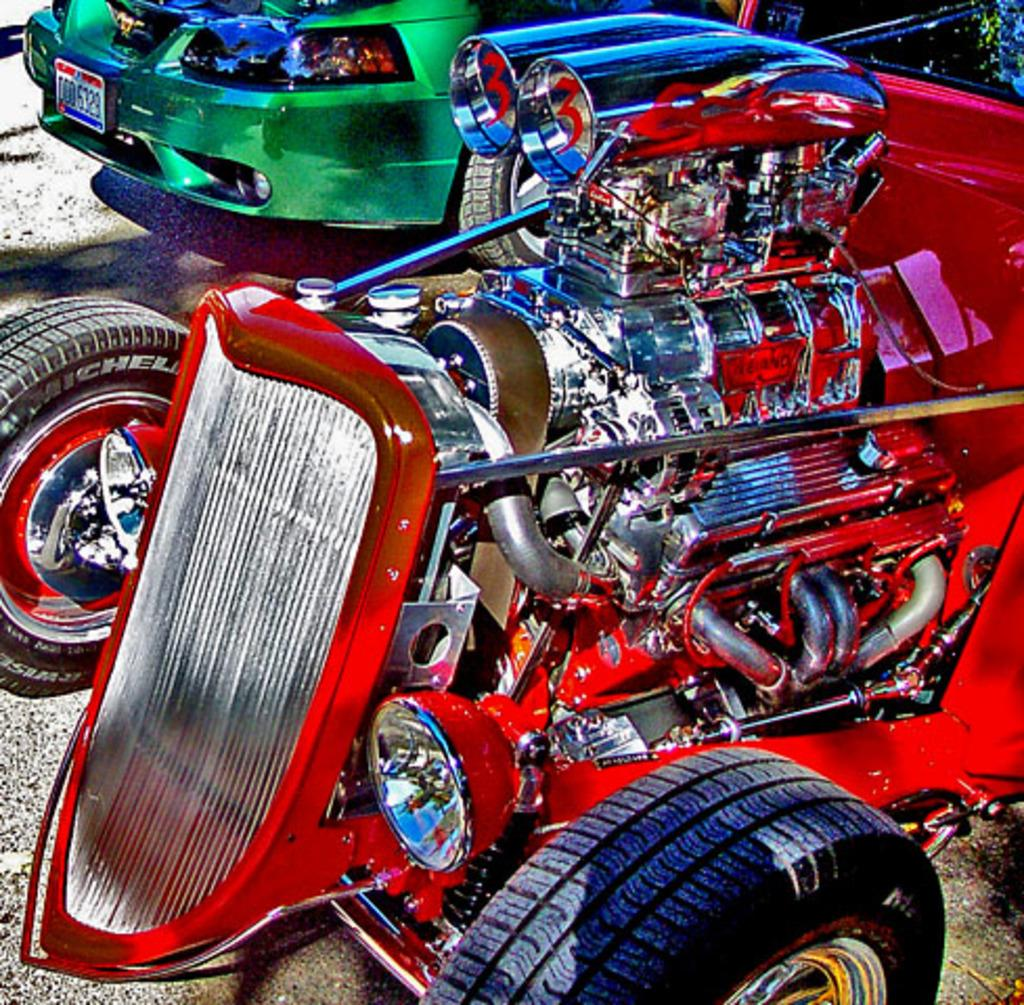What can be seen on the road in the image? There are cars parked on the road in the image. Can you describe any specific part of a car in the image? The engine of a car is visible in the image. What type of activity is the car involved in while parked on the road? The parked car is not involved in any activity in the image. What kind of trouble is the car experiencing in the image? There is no indication of trouble with the car in the image; it is simply parked on the road. 